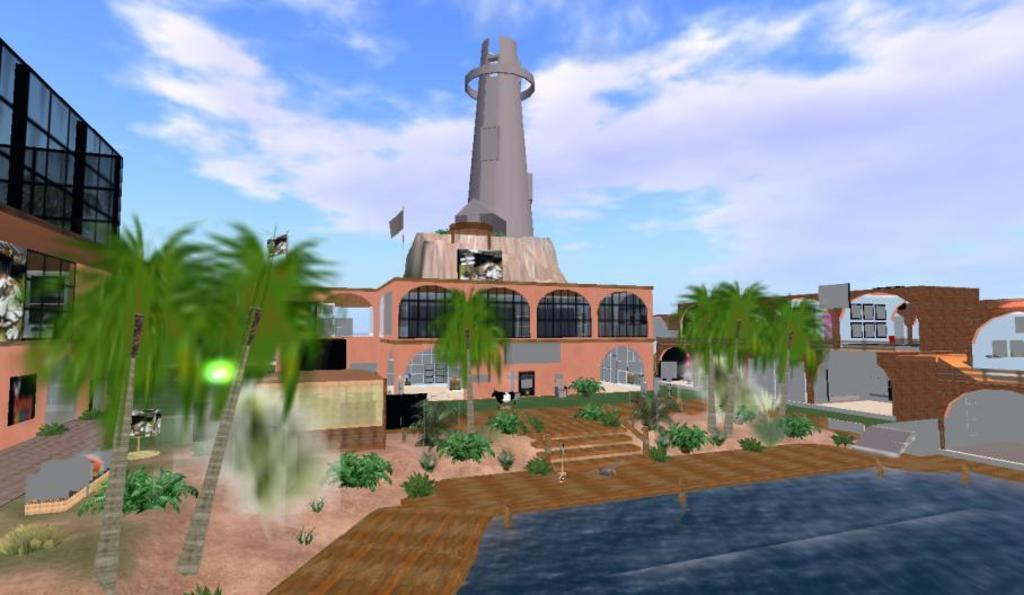What type of image is being described? The image is animated. What type of natural elements can be seen in the image? There are trees and plants in the image. What type of man-made structures are present in the image? There are buildings in the image. What is the ship's reaction to the storm in the image? There is no ship present in the image, so it is not possible to determine its reaction to a storm. 